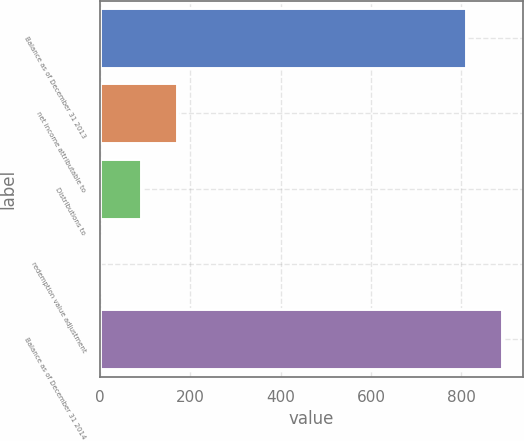Convert chart to OTSL. <chart><loc_0><loc_0><loc_500><loc_500><bar_chart><fcel>Balance as of December 31 2013<fcel>net income attributable to<fcel>Distributions to<fcel>redemption value adjustment<fcel>Balance as of December 31 2014<nl><fcel>810<fcel>171.9<fcel>91<fcel>1<fcel>890.9<nl></chart> 